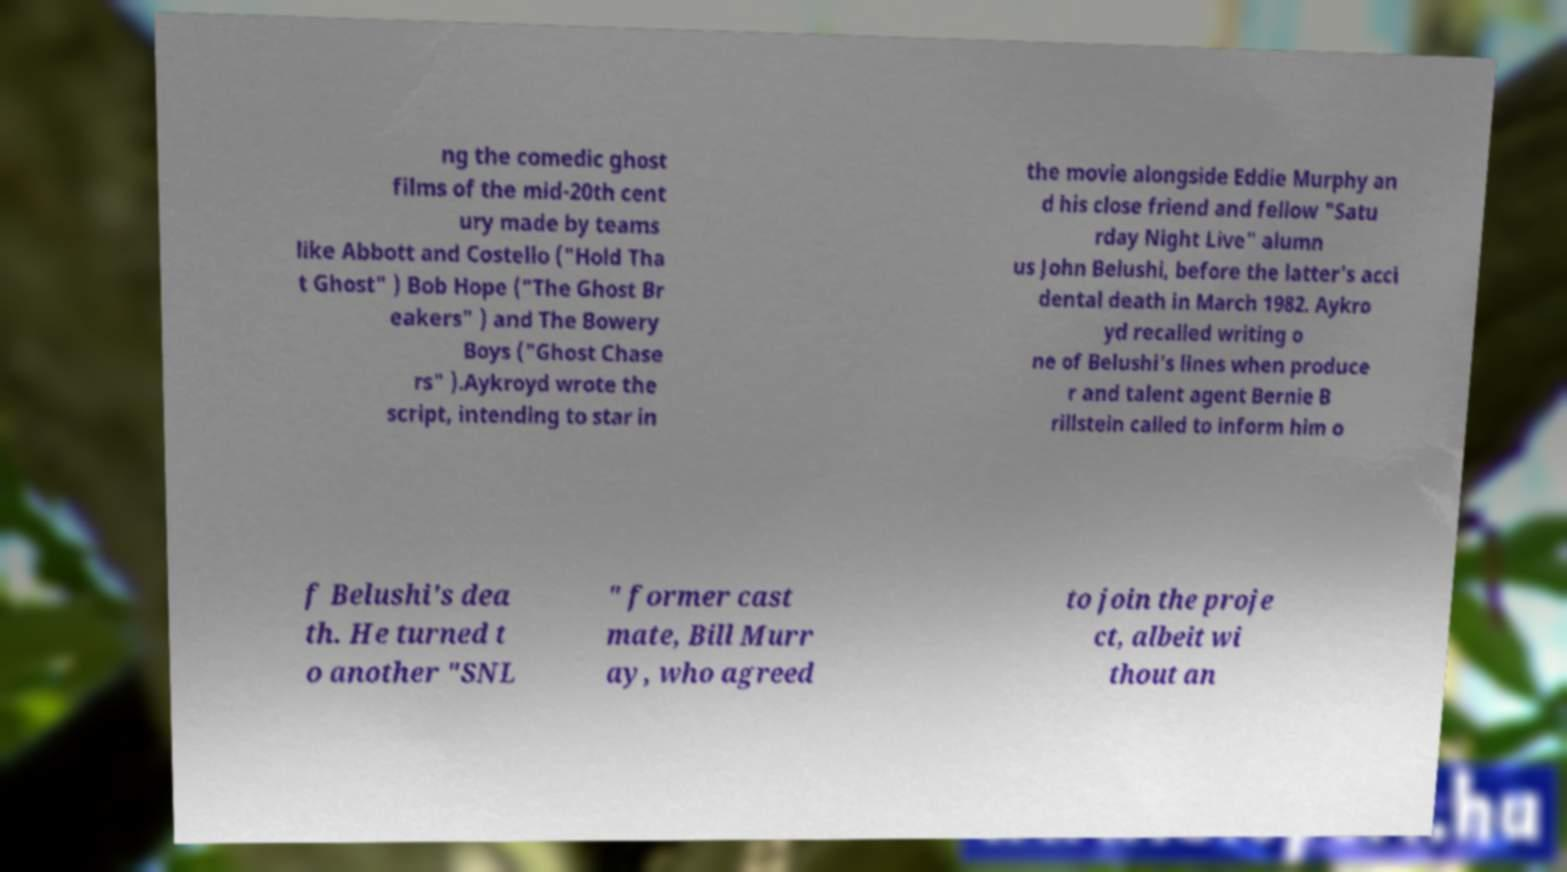For documentation purposes, I need the text within this image transcribed. Could you provide that? ng the comedic ghost films of the mid-20th cent ury made by teams like Abbott and Costello ("Hold Tha t Ghost" ) Bob Hope ("The Ghost Br eakers" ) and The Bowery Boys ("Ghost Chase rs" ).Aykroyd wrote the script, intending to star in the movie alongside Eddie Murphy an d his close friend and fellow "Satu rday Night Live" alumn us John Belushi, before the latter's acci dental death in March 1982. Aykro yd recalled writing o ne of Belushi's lines when produce r and talent agent Bernie B rillstein called to inform him o f Belushi's dea th. He turned t o another "SNL " former cast mate, Bill Murr ay, who agreed to join the proje ct, albeit wi thout an 